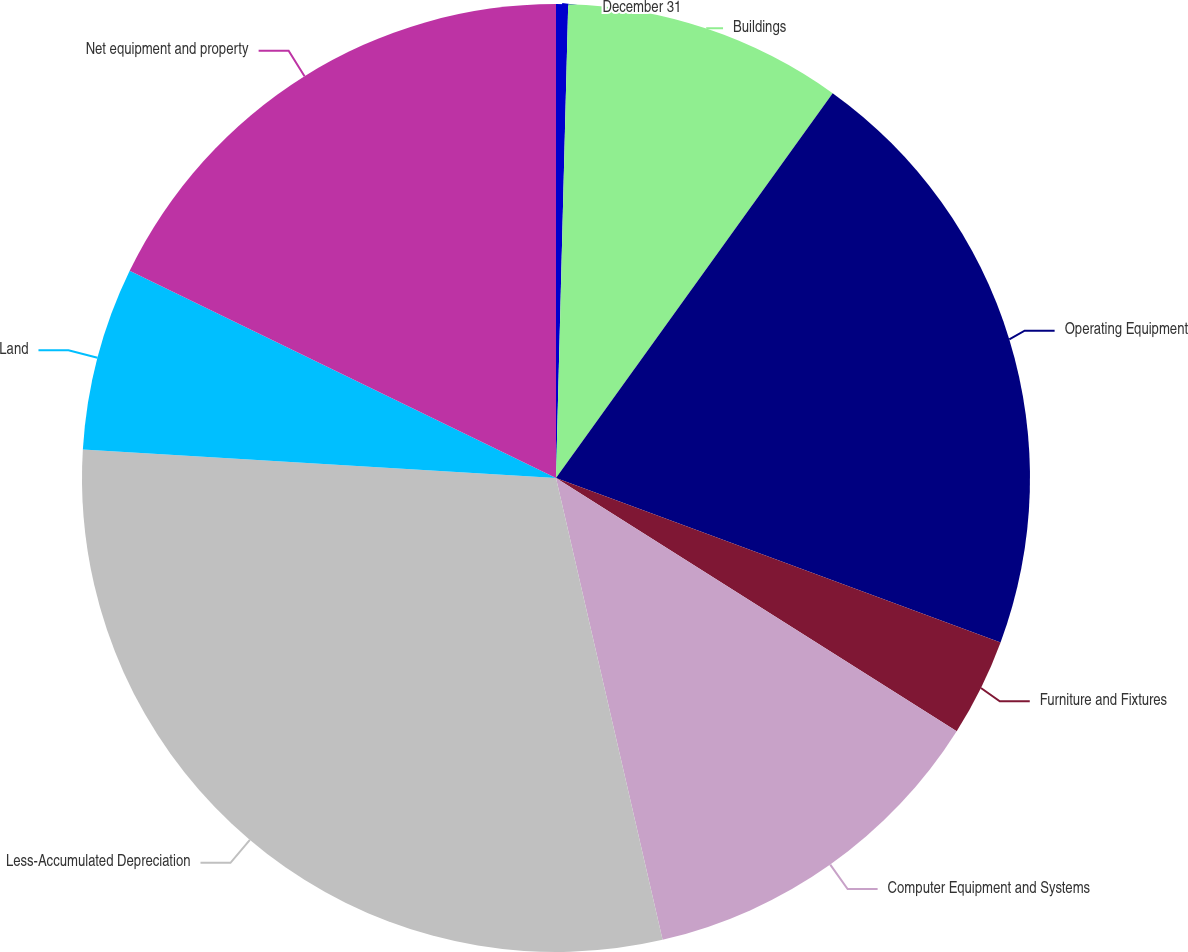<chart> <loc_0><loc_0><loc_500><loc_500><pie_chart><fcel>December 31<fcel>Buildings<fcel>Operating Equipment<fcel>Furniture and Fixtures<fcel>Computer Equipment and Systems<fcel>Less-Accumulated Depreciation<fcel>Land<fcel>Net equipment and property<nl><fcel>0.41%<fcel>9.51%<fcel>20.72%<fcel>3.33%<fcel>12.42%<fcel>29.57%<fcel>6.24%<fcel>17.8%<nl></chart> 